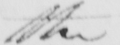Please provide the text content of this handwritten line. the 